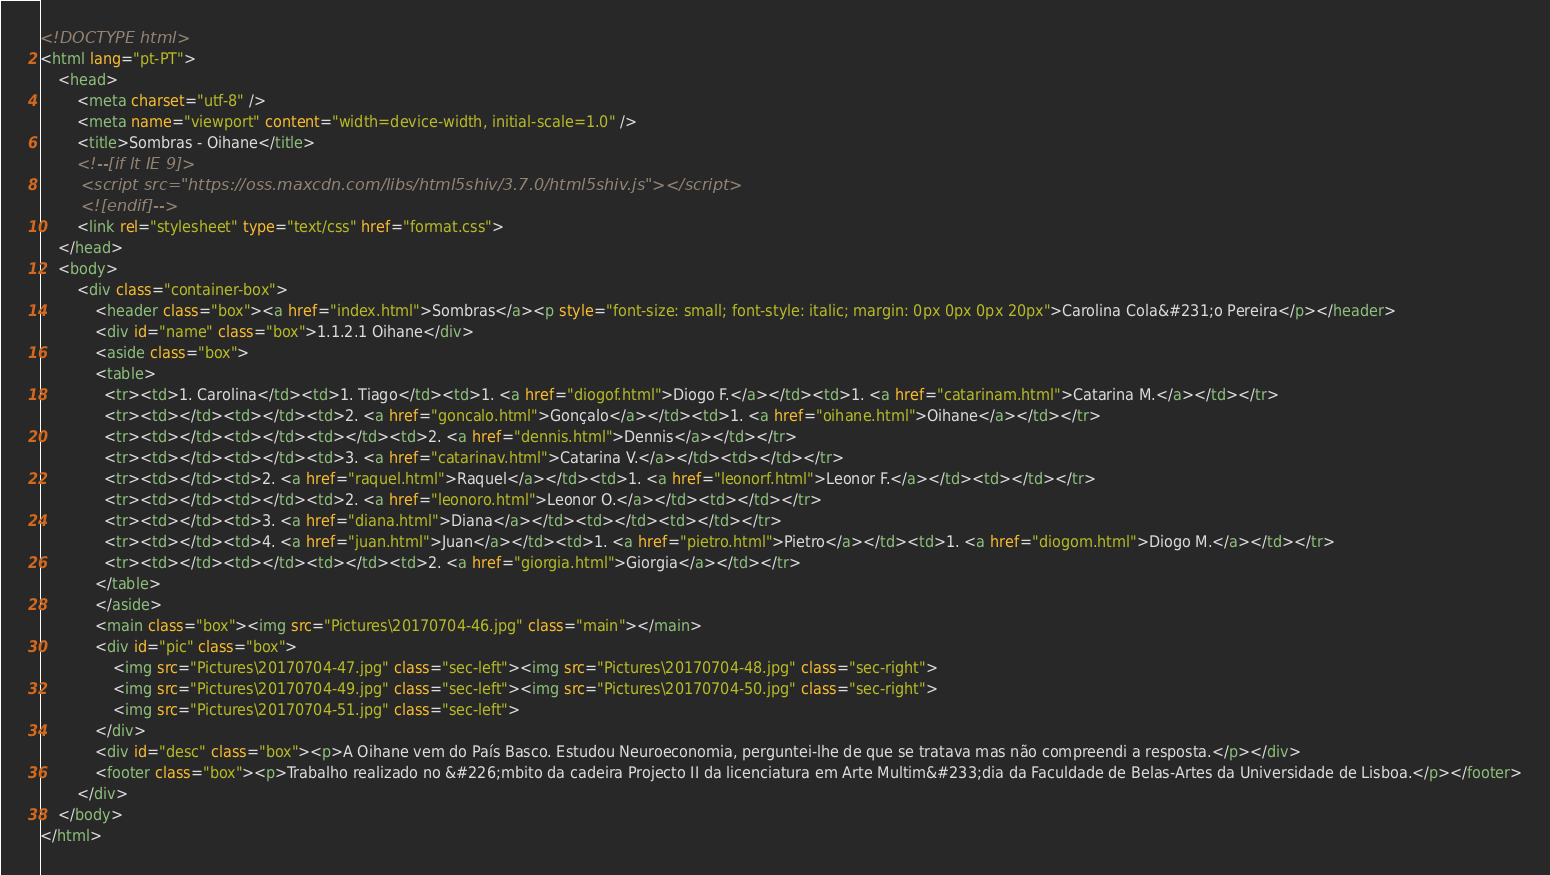<code> <loc_0><loc_0><loc_500><loc_500><_HTML_><!DOCTYPE html>
<html lang="pt-PT">
	<head>
		<meta charset="utf-8" />
		<meta name="viewport" content="width=device-width, initial-scale=1.0" />
		<title>Sombras - Oihane</title>
		<!--[if lt IE 9]>
		<script src="https://oss.maxcdn.com/libs/html5shiv/3.7.0/html5shiv.js"></script>
		<![endif]-->
		<link rel="stylesheet" type="text/css" href="format.css">
	</head>
	<body>
		<div class="container-box">
			<header class="box"><a href="index.html">Sombras</a><p style="font-size: small; font-style: italic; margin: 0px 0px 0px 20px">Carolina Cola&#231;o Pereira</p></header>
			<div id="name" class="box">1.1.2.1 Oihane</div>
			<aside class="box">
			<table>
			  <tr><td>1. Carolina</td><td>1. Tiago</td><td>1. <a href="diogof.html">Diogo F.</a></td><td>1. <a href="catarinam.html">Catarina M.</a></td></tr>
			  <tr><td></td><td></td><td>2. <a href="goncalo.html">Gonçalo</a></td><td>1. <a href="oihane.html">Oihane</a></td></tr>
			  <tr><td></td><td></td><td></td><td>2. <a href="dennis.html">Dennis</a></td></tr>
			  <tr><td></td><td></td><td>3. <a href="catarinav.html">Catarina V.</a></td><td></td></tr>
			  <tr><td></td><td>2. <a href="raquel.html">Raquel</a></td><td>1. <a href="leonorf.html">Leonor F.</a></td><td></td></tr>
			  <tr><td></td><td></td><td>2. <a href="leonoro.html">Leonor O.</a></td><td></td></tr>
			  <tr><td></td><td>3. <a href="diana.html">Diana</a></td><td></td><td></td></tr>
			  <tr><td></td><td>4. <a href="juan.html">Juan</a></td><td>1. <a href="pietro.html">Pietro</a></td><td>1. <a href="diogom.html">Diogo M.</a></td></tr>
			  <tr><td></td><td></td><td></td><td>2. <a href="giorgia.html">Giorgia</a></td></tr>
			</table>
			</aside>
			<main class="box"><img src="Pictures\20170704-46.jpg" class="main"></main>
			<div id="pic" class="box">
				<img src="Pictures\20170704-47.jpg" class="sec-left"><img src="Pictures\20170704-48.jpg" class="sec-right">
				<img src="Pictures\20170704-49.jpg" class="sec-left"><img src="Pictures\20170704-50.jpg" class="sec-right">
				<img src="Pictures\20170704-51.jpg" class="sec-left">
			</div>
			<div id="desc" class="box"><p>A Oihane vem do País Basco. Estudou Neuroeconomia, perguntei-lhe de que se tratava mas não compreendi a resposta.</p></div>
			<footer class="box"><p>Trabalho realizado no &#226;mbito da cadeira Projecto II da licenciatura em Arte Multim&#233;dia da Faculdade de Belas-Artes da Universidade de Lisboa.</p></footer>
		</div>
	</body>
</html></code> 